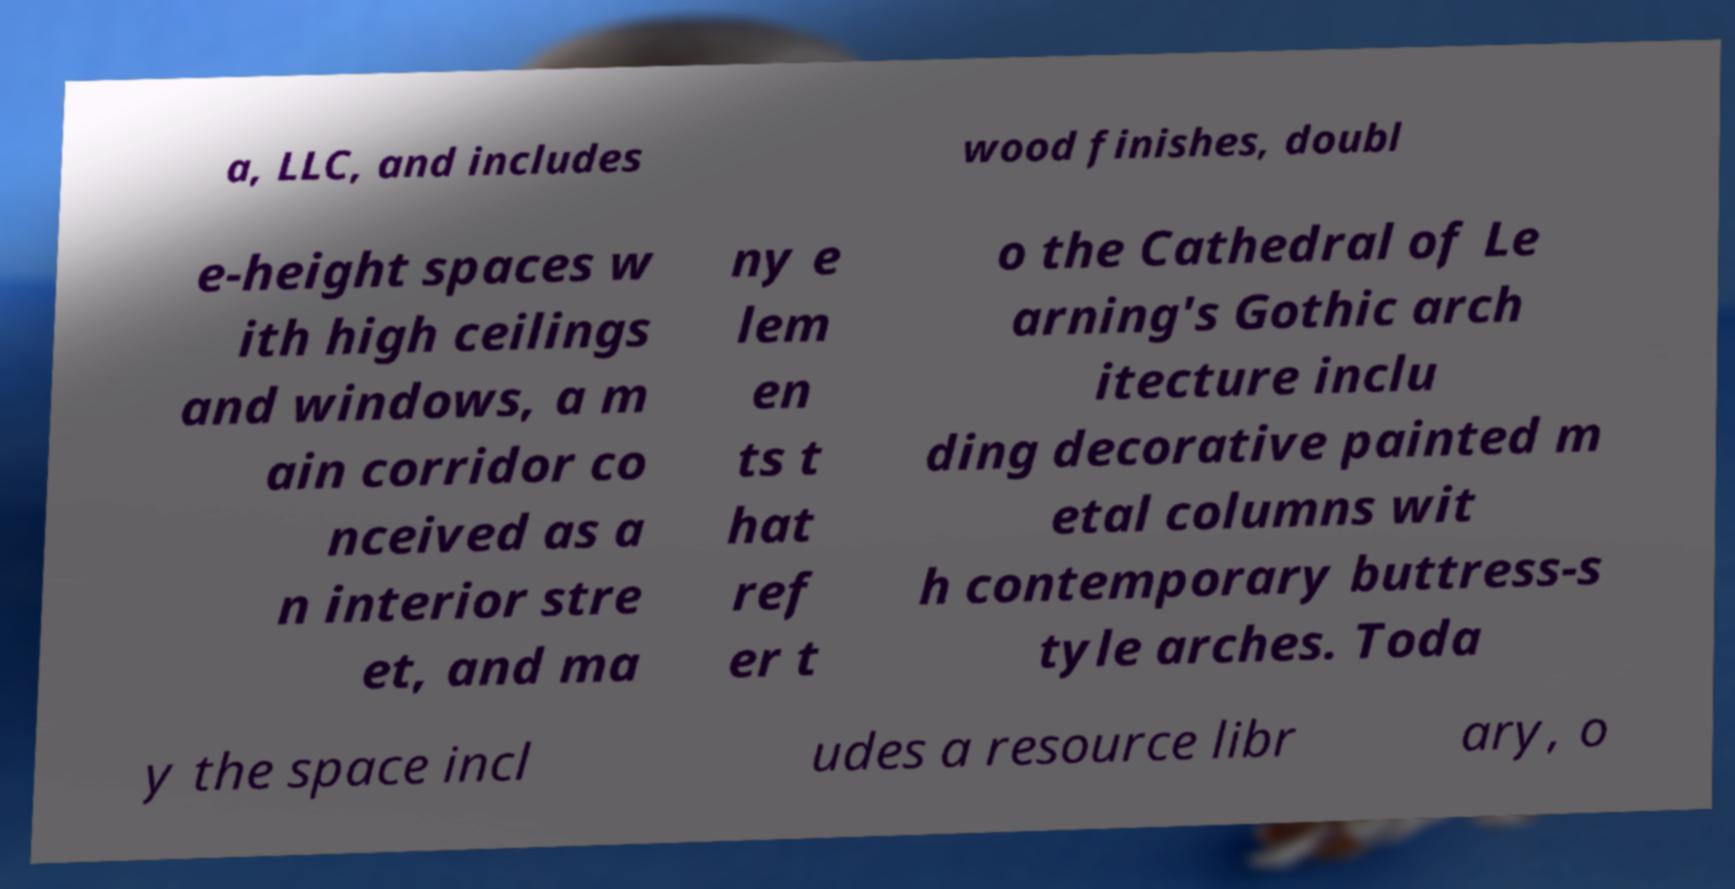Can you accurately transcribe the text from the provided image for me? a, LLC, and includes wood finishes, doubl e-height spaces w ith high ceilings and windows, a m ain corridor co nceived as a n interior stre et, and ma ny e lem en ts t hat ref er t o the Cathedral of Le arning's Gothic arch itecture inclu ding decorative painted m etal columns wit h contemporary buttress-s tyle arches. Toda y the space incl udes a resource libr ary, o 